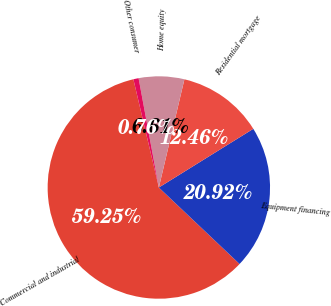Convert chart. <chart><loc_0><loc_0><loc_500><loc_500><pie_chart><fcel>Commercial and industrial<fcel>Equipment financing<fcel>Residential mortgage<fcel>Home equity<fcel>Other consumer<nl><fcel>59.26%<fcel>20.92%<fcel>12.46%<fcel>6.61%<fcel>0.76%<nl></chart> 